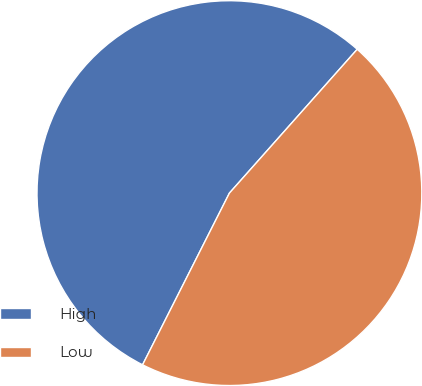Convert chart. <chart><loc_0><loc_0><loc_500><loc_500><pie_chart><fcel>High<fcel>Low<nl><fcel>54.11%<fcel>45.89%<nl></chart> 